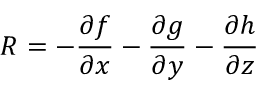<formula> <loc_0><loc_0><loc_500><loc_500>R = - \frac { \partial f } { \partial x } - \frac { \partial g } { \partial y } - \frac { \partial h } { \partial z }</formula> 